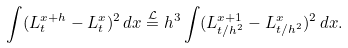<formula> <loc_0><loc_0><loc_500><loc_500>\int ( L ^ { x + h } _ { t } - L ^ { x } _ { t } ) ^ { 2 } \, d x \stackrel { \mathcal { L } } { = } h ^ { 3 } \int ( L ^ { x + 1 } _ { t / h ^ { 2 } } - L ^ { x } _ { t / h ^ { 2 } } ) ^ { 2 } \, d x .</formula> 